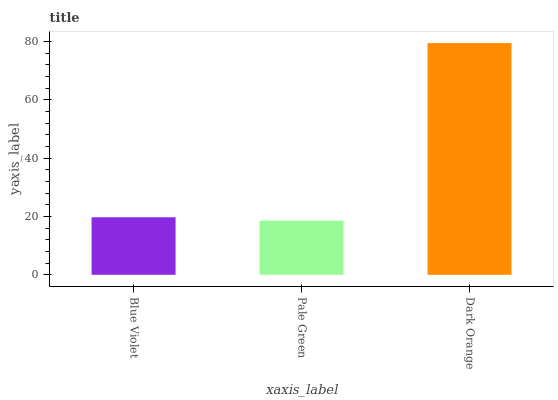Is Pale Green the minimum?
Answer yes or no. Yes. Is Dark Orange the maximum?
Answer yes or no. Yes. Is Dark Orange the minimum?
Answer yes or no. No. Is Pale Green the maximum?
Answer yes or no. No. Is Dark Orange greater than Pale Green?
Answer yes or no. Yes. Is Pale Green less than Dark Orange?
Answer yes or no. Yes. Is Pale Green greater than Dark Orange?
Answer yes or no. No. Is Dark Orange less than Pale Green?
Answer yes or no. No. Is Blue Violet the high median?
Answer yes or no. Yes. Is Blue Violet the low median?
Answer yes or no. Yes. Is Dark Orange the high median?
Answer yes or no. No. Is Dark Orange the low median?
Answer yes or no. No. 